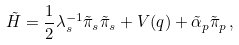<formula> <loc_0><loc_0><loc_500><loc_500>\tilde { H } = \frac { 1 } { 2 } \lambda _ { s } ^ { - 1 } \tilde { \pi } _ { s } \tilde { \pi } _ { s } + V ( q ) + \tilde { \alpha } _ { p } \tilde { \pi } _ { p } \, ,</formula> 